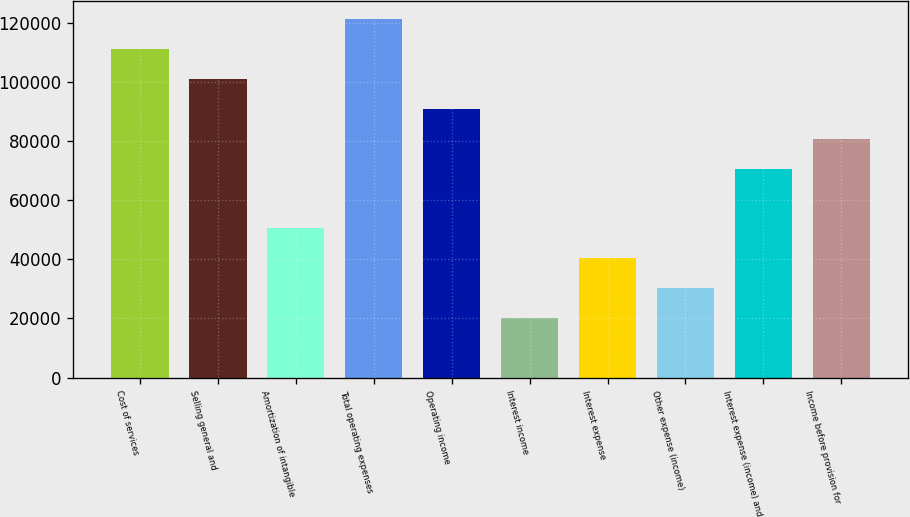Convert chart. <chart><loc_0><loc_0><loc_500><loc_500><bar_chart><fcel>Cost of services<fcel>Selling general and<fcel>Amortization of intangible<fcel>Total operating expenses<fcel>Operating income<fcel>Interest income<fcel>Interest expense<fcel>Other expense (income)<fcel>Interest expense (income) and<fcel>Income before provision for<nl><fcel>111174<fcel>101067<fcel>50533.6<fcel>121280<fcel>90960.3<fcel>20213.5<fcel>40426.9<fcel>30320.2<fcel>70747<fcel>80853.6<nl></chart> 